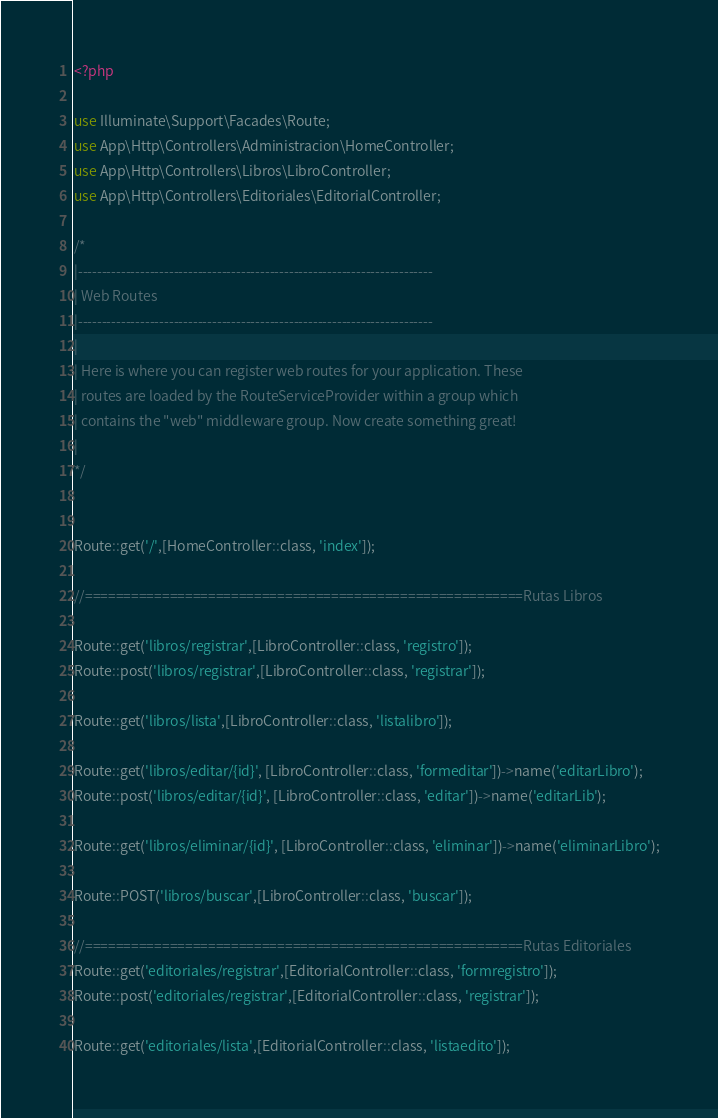Convert code to text. <code><loc_0><loc_0><loc_500><loc_500><_PHP_><?php

use Illuminate\Support\Facades\Route;
use App\Http\Controllers\Administracion\HomeController;
use App\Http\Controllers\Libros\LibroController;
use App\Http\Controllers\Editoriales\EditorialController;

/*
|--------------------------------------------------------------------------
| Web Routes
|--------------------------------------------------------------------------
|
| Here is where you can register web routes for your application. These
| routes are loaded by the RouteServiceProvider within a group which
| contains the "web" middleware group. Now create something great!
|
*/


Route::get('/',[HomeController::class, 'index']);

//=========================================================Rutas Libros

Route::get('libros/registrar',[LibroController::class, 'registro']);
Route::post('libros/registrar',[LibroController::class, 'registrar']);

Route::get('libros/lista',[LibroController::class, 'listalibro']);

Route::get('libros/editar/{id}', [LibroController::class, 'formeditar'])->name('editarLibro');
Route::post('libros/editar/{id}', [LibroController::class, 'editar'])->name('editarLib');

Route::get('libros/eliminar/{id}', [LibroController::class, 'eliminar'])->name('eliminarLibro');

Route::POST('libros/buscar',[LibroController::class, 'buscar']);

//=========================================================Rutas Editoriales
Route::get('editoriales/registrar',[EditorialController::class, 'formregistro']);
Route::post('editoriales/registrar',[EditorialController::class, 'registrar']);

Route::get('editoriales/lista',[EditorialController::class, 'listaedito']);</code> 